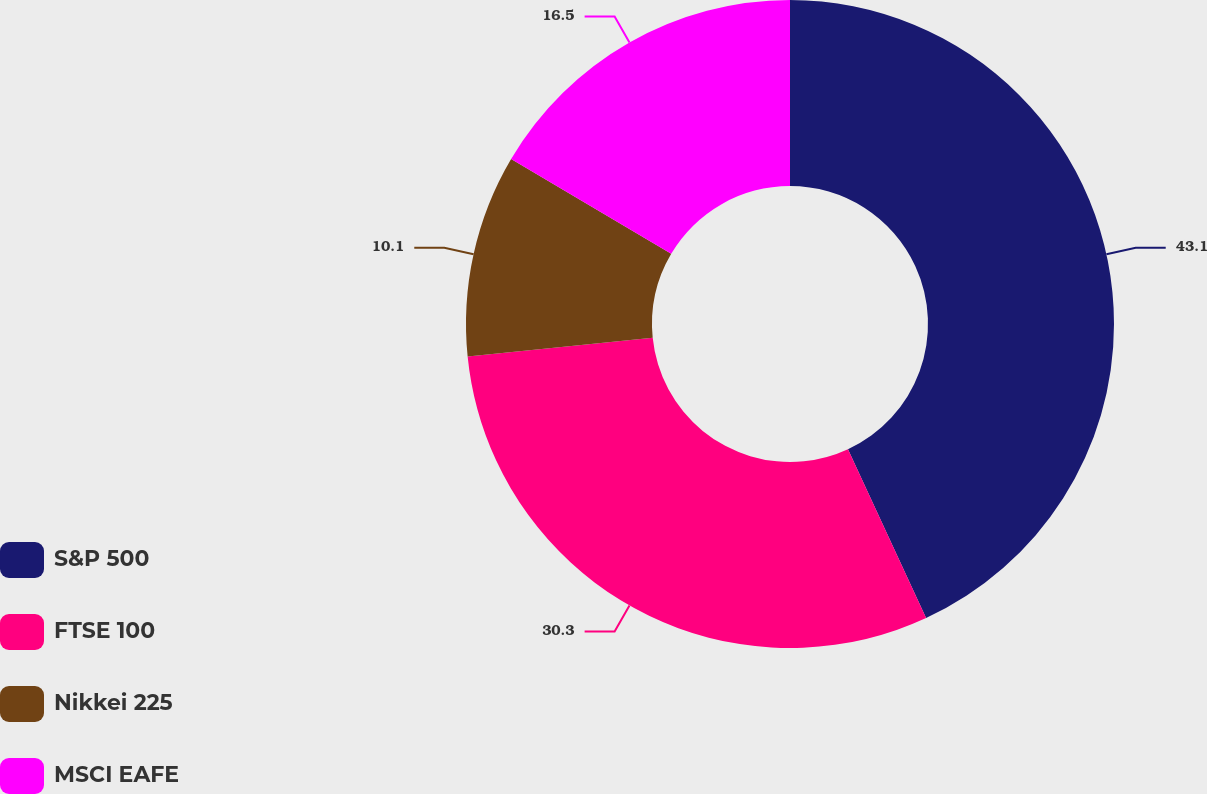Convert chart to OTSL. <chart><loc_0><loc_0><loc_500><loc_500><pie_chart><fcel>S&P 500<fcel>FTSE 100<fcel>Nikkei 225<fcel>MSCI EAFE<nl><fcel>43.1%<fcel>30.3%<fcel>10.1%<fcel>16.5%<nl></chart> 